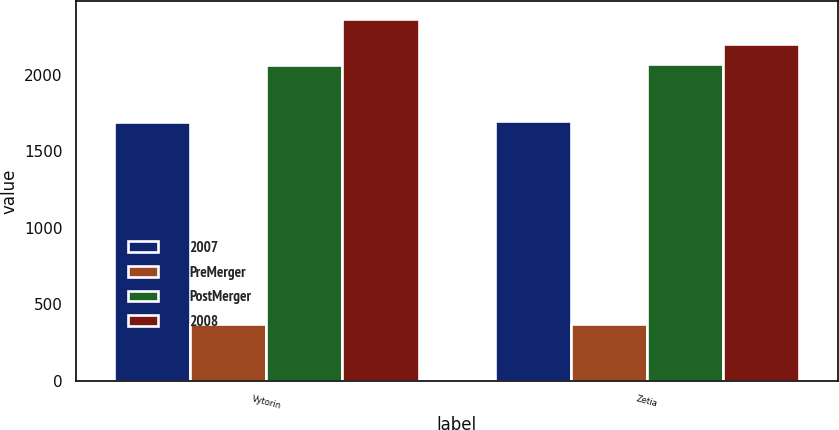<chart> <loc_0><loc_0><loc_500><loc_500><stacked_bar_chart><ecel><fcel>Vytorin<fcel>Zetia<nl><fcel>2007<fcel>1689.5<fcel>1697.7<nl><fcel>PreMerger<fcel>370.6<fcel>370.3<nl><fcel>PostMerger<fcel>2060.1<fcel>2068<nl><fcel>2008<fcel>2360<fcel>2201.1<nl></chart> 